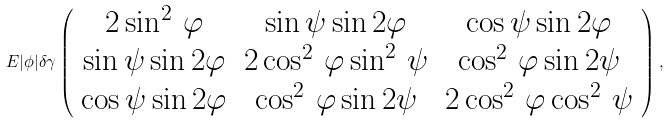Convert formula to latex. <formula><loc_0><loc_0><loc_500><loc_500>E | \phi | \delta \gamma \left ( \begin{array} { c c c } { { 2 \sin ^ { 2 } \, \varphi } } & { \sin \psi \sin 2 \varphi } & { \cos \psi \sin 2 \varphi } \\ { \sin \psi \sin 2 \varphi } & { { 2 \cos ^ { 2 } \, \varphi \sin ^ { 2 } \, \psi } } & { { \cos ^ { 2 } \, \varphi \sin 2 \psi } } \\ { \cos \psi \sin 2 \varphi } & { { \cos ^ { 2 } \, \varphi \sin 2 \psi } } & { { 2 \cos ^ { 2 } \, \varphi \cos ^ { 2 } \, \psi } } \end{array} \right ) ,</formula> 